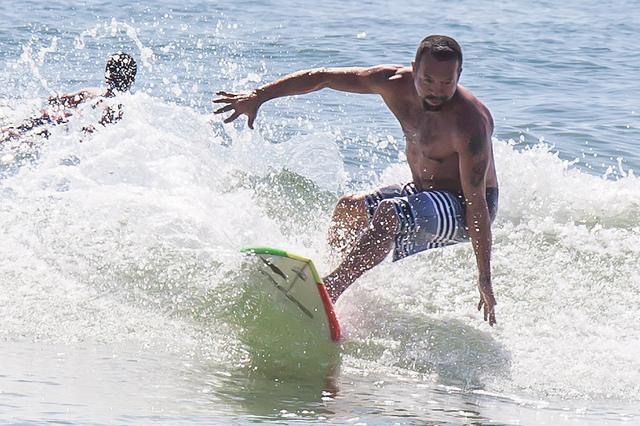What is the surfer doing to the wave?

Choices:
A) splitting
B) carving
C) cutting
D) slicing carving 